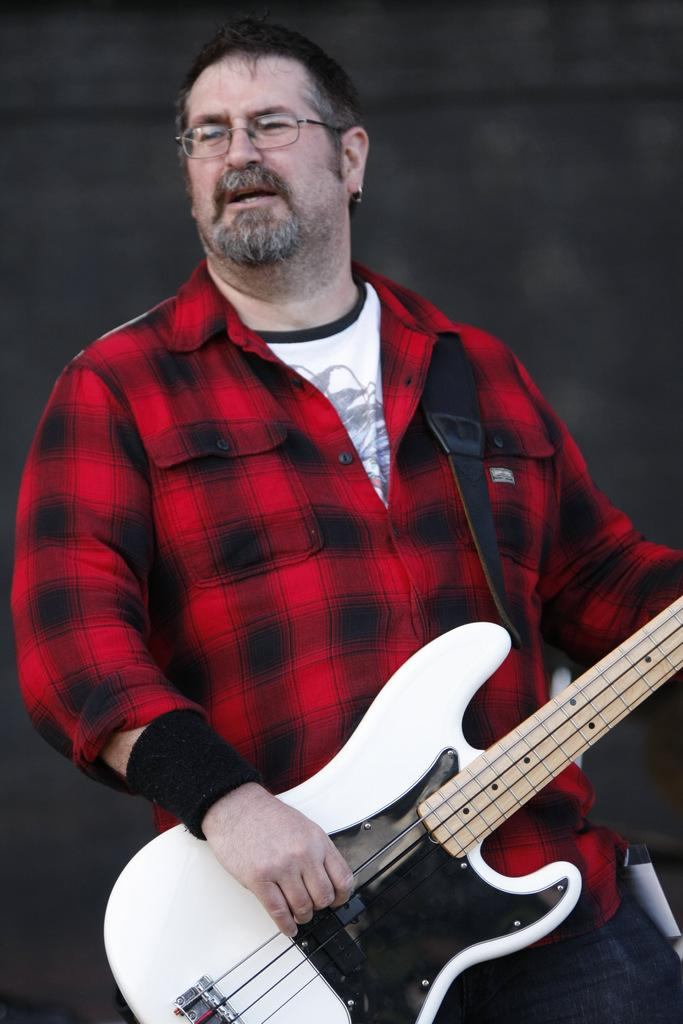Who is present in the image? There is a person in the image. What is the person wearing? The person is wearing a red dress. What is the person holding in their hand? The person is holding a guitar in their hand. How many fingers are helping the goat in the image? There is no goat present in the image, and therefore no fingers are helping a goat. 